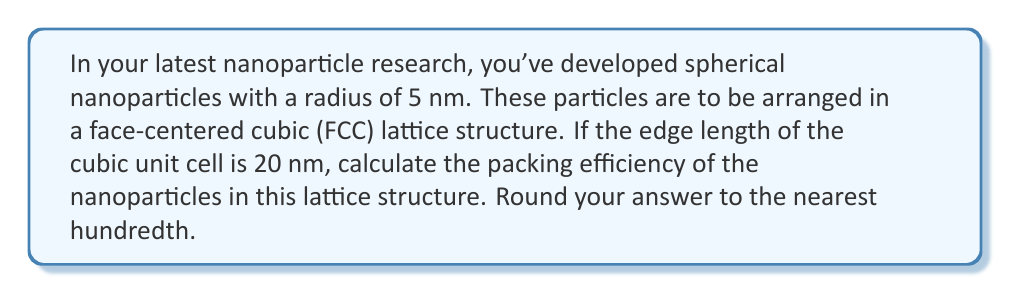What is the answer to this math problem? Let's approach this step-by-step:

1) In an FCC lattice, there are 4 whole spheres per unit cell:
   - 1/8 of a sphere at each of the 8 corners (8 * 1/8 = 1)
   - 1/2 of a sphere on each of the 6 faces (6 * 1/2 = 3)
   - Total: 1 + 3 = 4 spheres

2) The volume of the cubic unit cell is:
   $$V_{cell} = a^3 = 20^3 = 8000 \text{ nm}^3$$
   where $a$ is the edge length of the cube.

3) The volume of a single spherical nanoparticle is:
   $$V_{sphere} = \frac{4}{3}\pi r^3 = \frac{4}{3}\pi 5^3 \approx 523.60 \text{ nm}^3$$

4) The total volume occupied by spheres in one unit cell is:
   $$V_{occupied} = 4 * V_{sphere} = 4 * 523.60 = 2094.40 \text{ nm}^3$$

5) The packing efficiency is the ratio of the volume occupied by spheres to the total volume of the unit cell:
   $$\text{Packing Efficiency} = \frac{V_{occupied}}{V_{cell}} * 100\%$$

6) Substituting the values:
   $$\text{Packing Efficiency} = \frac{2094.40}{8000} * 100\% \approx 26.18\%$$

7) Rounding to the nearest hundredth:
   $$\text{Packing Efficiency} \approx 26.18\%$$
Answer: 26.18% 